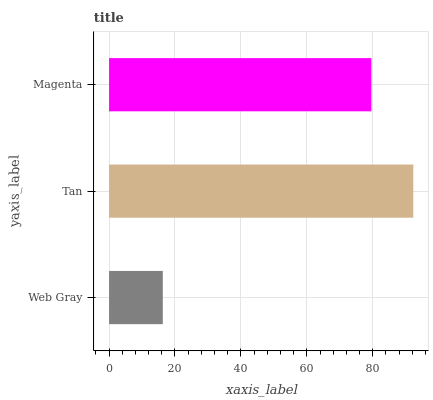Is Web Gray the minimum?
Answer yes or no. Yes. Is Tan the maximum?
Answer yes or no. Yes. Is Magenta the minimum?
Answer yes or no. No. Is Magenta the maximum?
Answer yes or no. No. Is Tan greater than Magenta?
Answer yes or no. Yes. Is Magenta less than Tan?
Answer yes or no. Yes. Is Magenta greater than Tan?
Answer yes or no. No. Is Tan less than Magenta?
Answer yes or no. No. Is Magenta the high median?
Answer yes or no. Yes. Is Magenta the low median?
Answer yes or no. Yes. Is Web Gray the high median?
Answer yes or no. No. Is Tan the low median?
Answer yes or no. No. 